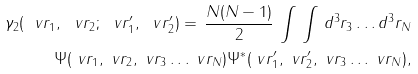Convert formula to latex. <formula><loc_0><loc_0><loc_500><loc_500>\gamma _ { 2 } ( \ v r _ { 1 } , \ v r _ { 2 } ; \ v r ^ { \prime } _ { 1 } , \ v r ^ { \prime } _ { 2 } ) = \, \frac { N ( N - 1 ) } { 2 } \, \int \, \int \, d ^ { 3 } r _ { 3 } \dots d ^ { 3 } r _ { N } \\ \Psi ( \ v r _ { 1 } , \ v r _ { 2 } , \ v r _ { 3 } \dots \ v r _ { N } ) \Psi ^ { * } ( \ v r ^ { \prime } _ { 1 } , \ v r ^ { \prime } _ { 2 } , \ v r _ { 3 } \dots \ v r _ { N } ) ,</formula> 